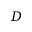<formula> <loc_0><loc_0><loc_500><loc_500>D</formula> 